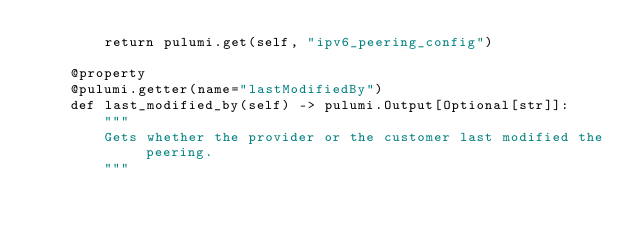<code> <loc_0><loc_0><loc_500><loc_500><_Python_>        return pulumi.get(self, "ipv6_peering_config")

    @property
    @pulumi.getter(name="lastModifiedBy")
    def last_modified_by(self) -> pulumi.Output[Optional[str]]:
        """
        Gets whether the provider or the customer last modified the peering.
        """</code> 